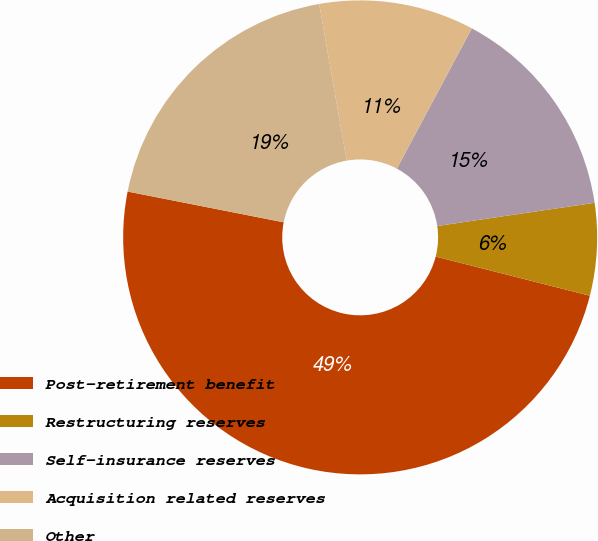<chart> <loc_0><loc_0><loc_500><loc_500><pie_chart><fcel>Post-retirement benefit<fcel>Restructuring reserves<fcel>Self-insurance reserves<fcel>Acquisition related reserves<fcel>Other<nl><fcel>49.14%<fcel>6.29%<fcel>14.86%<fcel>10.57%<fcel>19.14%<nl></chart> 